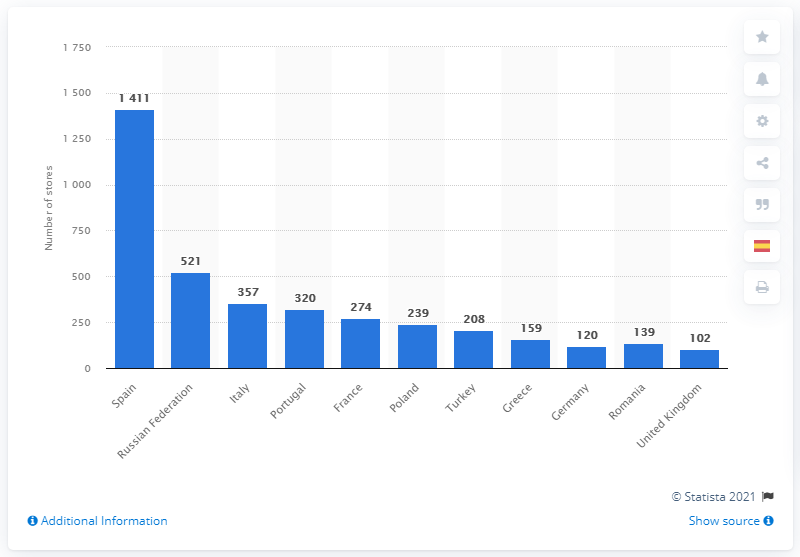Give some essential details in this illustration. The Inditex group's stores were located in Spain, where 36.6% of them were based. 